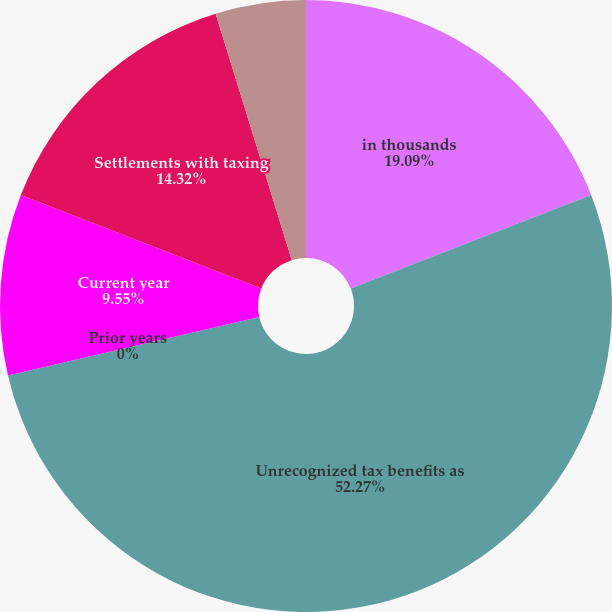<chart> <loc_0><loc_0><loc_500><loc_500><pie_chart><fcel>in thousands<fcel>Unrecognized tax benefits as<fcel>Prior years<fcel>Current year<fcel>Settlements with taxing<fcel>Expiration of applicable<nl><fcel>19.09%<fcel>52.27%<fcel>0.0%<fcel>9.55%<fcel>14.32%<fcel>4.77%<nl></chart> 